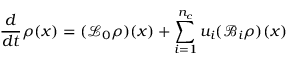Convert formula to latex. <formula><loc_0><loc_0><loc_500><loc_500>\frac { d } { d t } \rho ( x ) = ( \mathcal { L } _ { 0 } \rho ) ( x ) + \sum _ { i = 1 } ^ { n _ { c } } u _ { i } ( \mathcal { B } _ { i } \rho ) ( x )</formula> 